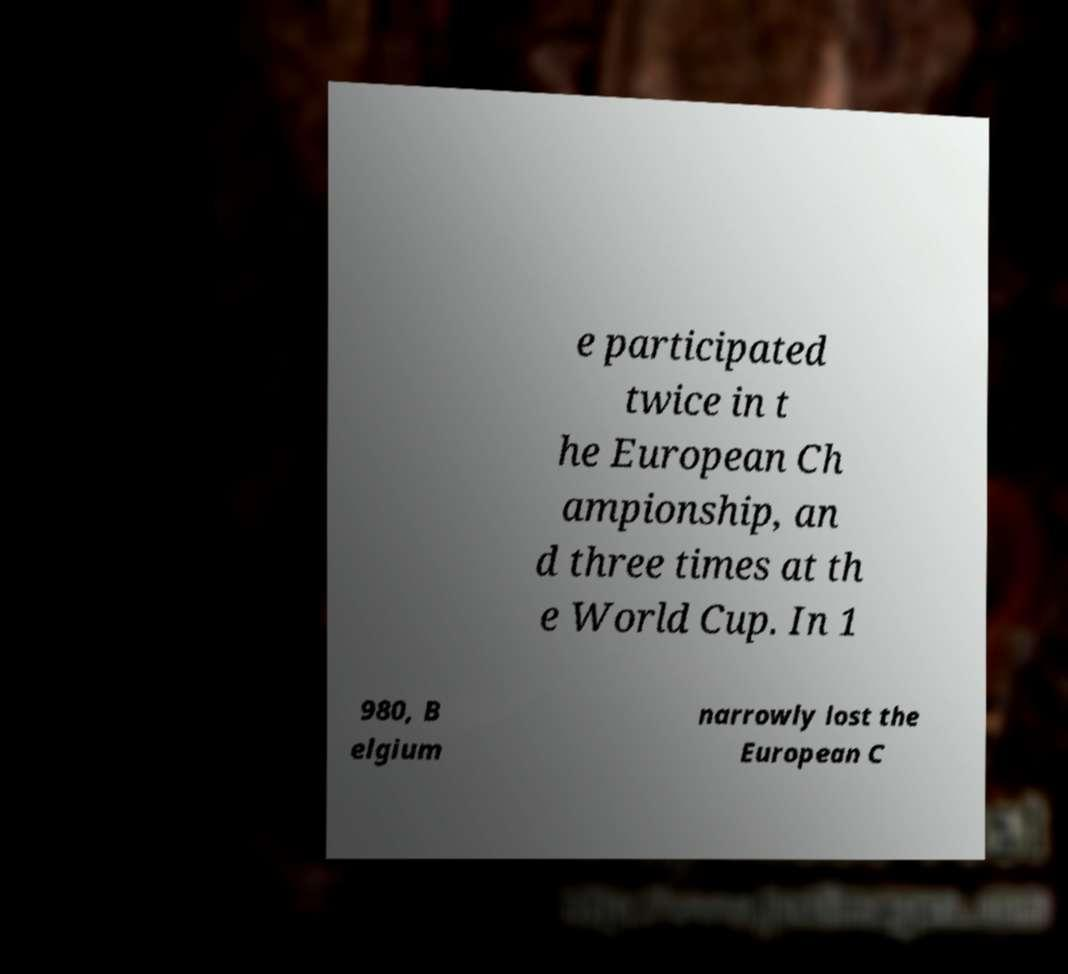Please identify and transcribe the text found in this image. e participated twice in t he European Ch ampionship, an d three times at th e World Cup. In 1 980, B elgium narrowly lost the European C 